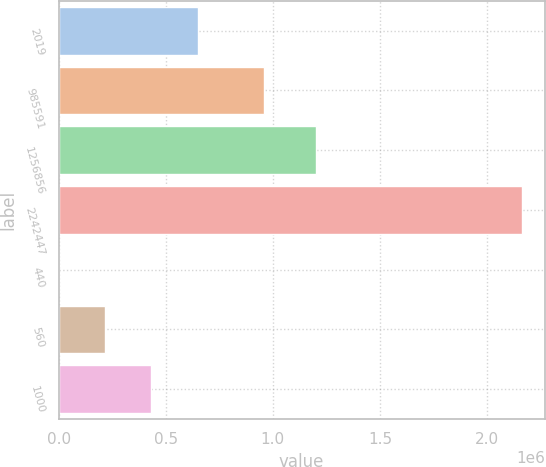Convert chart. <chart><loc_0><loc_0><loc_500><loc_500><bar_chart><fcel>2019<fcel>985591<fcel>1256856<fcel>2242447<fcel>440<fcel>560<fcel>1000<nl><fcel>648453<fcel>960108<fcel>1.2013e+06<fcel>2.16141e+06<fcel>44.4<fcel>216181<fcel>432317<nl></chart> 